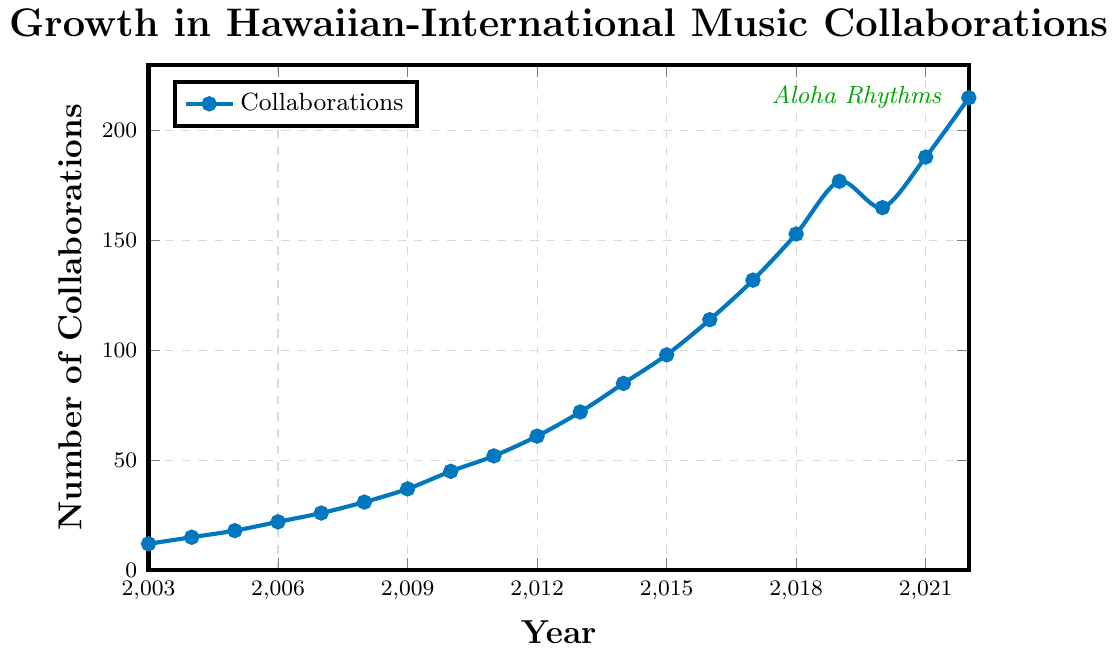How many collaborations were there in 2018? Locate the year 2018 on the x-axis and find the corresponding y-axis value for collaborations.
Answer: 153 What is the difference in the number of collaborations between 2010 and 2020? Find the collaborations in 2010 (45) and 2020 (165). Compute the difference: 165 - 45.
Answer: 120 In which year did the number of collaborations first exceed 100? Trace along the x-axis until you find the first year where the y-axis value surpasses 100.
Answer: 2016 By how much did the number of collaborations increase from 2003 to 2022? Record the collaborations in 2003 (12) and 2022 (215). Calculate the increase: 215 - 12.
Answer: 203 How much did the number of collaborations change from 2019 to 2020? Find the values for 2019 (177) and 2020 (165). Compute the change: 177 - 165.
Answer: 12 Between which consecutive years was the largest increase in collaborations? Compare yearly increases: 2003-2004 (3), 2004-2005 (3), ... , to 2021-2022 (27). Identify the maximum increase.
Answer: 2011 to 2012 Was there any year when the number of collaborations decreased? Which year? Check each year's value to see if a subsequent year shows a decrease. The collaborations decreased from 2019 to 2020.
Answer: 2020 What is the average number of collaborations from 2015 to 2017? Sum the values for 2015 (98), 2016 (114), and 2017 (132): 98 + 114 + 132 = 344. Then divide by 3: 344/3.
Answer: 114.67 Compare the collaborations in the years 2009 and 2019. Which year had more and by how much? Find the collaborations in 2009 (37) and 2019 (177). Compute the difference: 177 - 37.
Answer: 2019, 140 What was the trend in the number of collaborations from 2003 to 2022? Observe whether the line generally slopes upwards or downwards.
Answer: Upward trend 